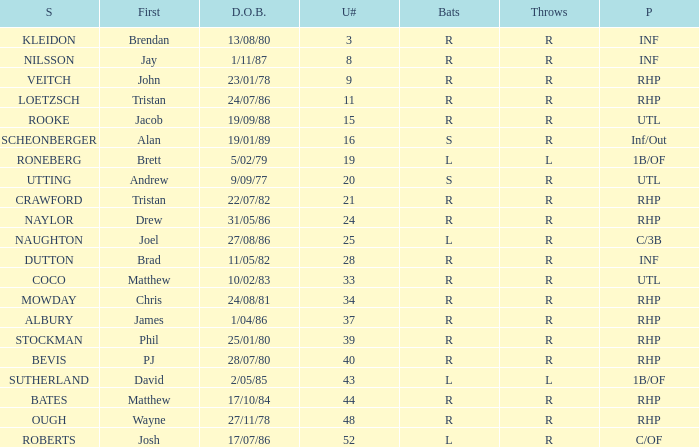Which Uni # has a Surname of ough? 48.0. 